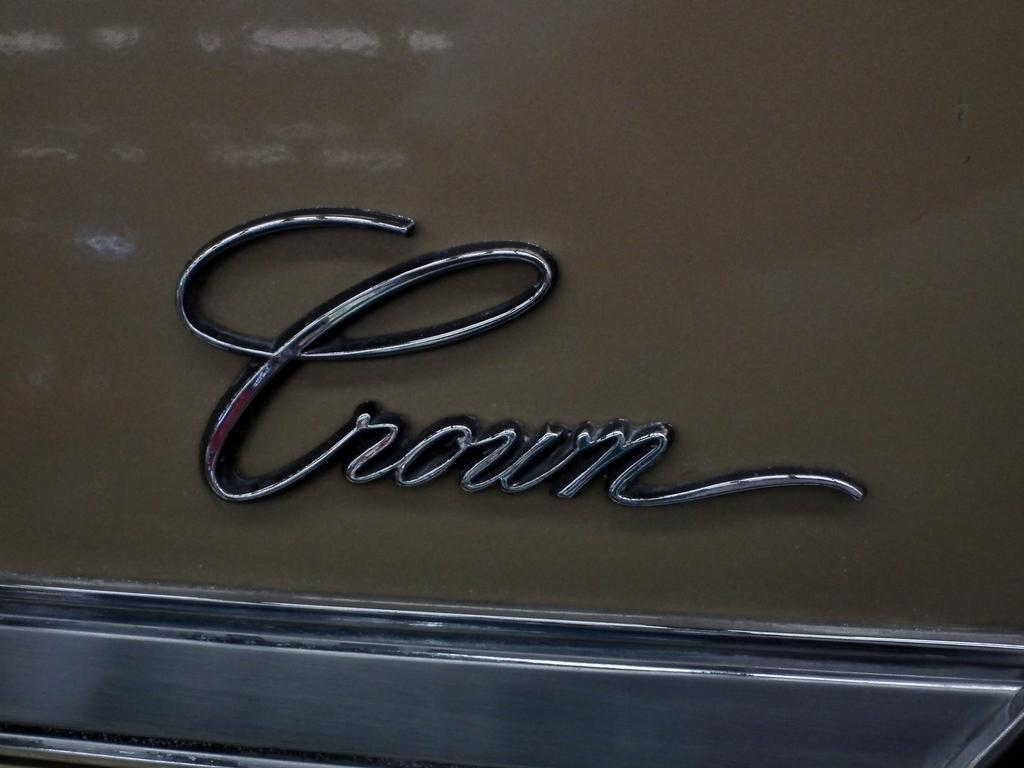What type of object in the image resembles a part of a vehicle? There is an object in the image that resembles a part of a vehicle. Can you describe the text visible on the vehicle? Unfortunately, the specific text on the vehicle cannot be determined from the provided facts. How many balls are being juggled by the magician in the image? There is no magician or balls present in the image. What type of basket is being used to collect the magic items in the image? There is no magic or basket present in the image. 